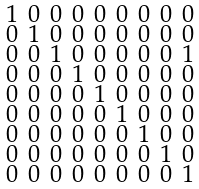<formula> <loc_0><loc_0><loc_500><loc_500>\begin{smallmatrix} 1 & 0 & 0 & 0 & 0 & 0 & 0 & 0 & 0 \\ 0 & 1 & 0 & 0 & 0 & 0 & 0 & 0 & 0 \\ 0 & 0 & 1 & 0 & 0 & 0 & 0 & 0 & 1 \\ 0 & 0 & 0 & 1 & 0 & 0 & 0 & 0 & 0 \\ 0 & 0 & 0 & 0 & 1 & 0 & 0 & 0 & 0 \\ 0 & 0 & 0 & 0 & 0 & 1 & 0 & 0 & 0 \\ 0 & 0 & 0 & 0 & 0 & 0 & 1 & 0 & 0 \\ 0 & 0 & 0 & 0 & 0 & 0 & 0 & 1 & 0 \\ 0 & 0 & 0 & 0 & 0 & 0 & 0 & 0 & 1 \end{smallmatrix}</formula> 